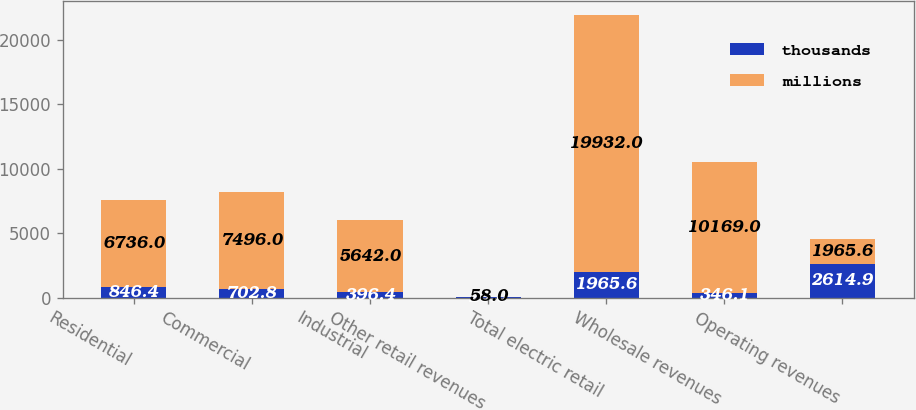Convert chart to OTSL. <chart><loc_0><loc_0><loc_500><loc_500><stacked_bar_chart><ecel><fcel>Residential<fcel>Commercial<fcel>Industrial<fcel>Other retail revenues<fcel>Total electric retail<fcel>Wholesale revenues<fcel>Operating revenues<nl><fcel>thousands<fcel>846.4<fcel>702.8<fcel>396.4<fcel>20<fcel>1965.6<fcel>346.1<fcel>2614.9<nl><fcel>millions<fcel>6736<fcel>7496<fcel>5642<fcel>58<fcel>19932<fcel>10169<fcel>1965.6<nl></chart> 